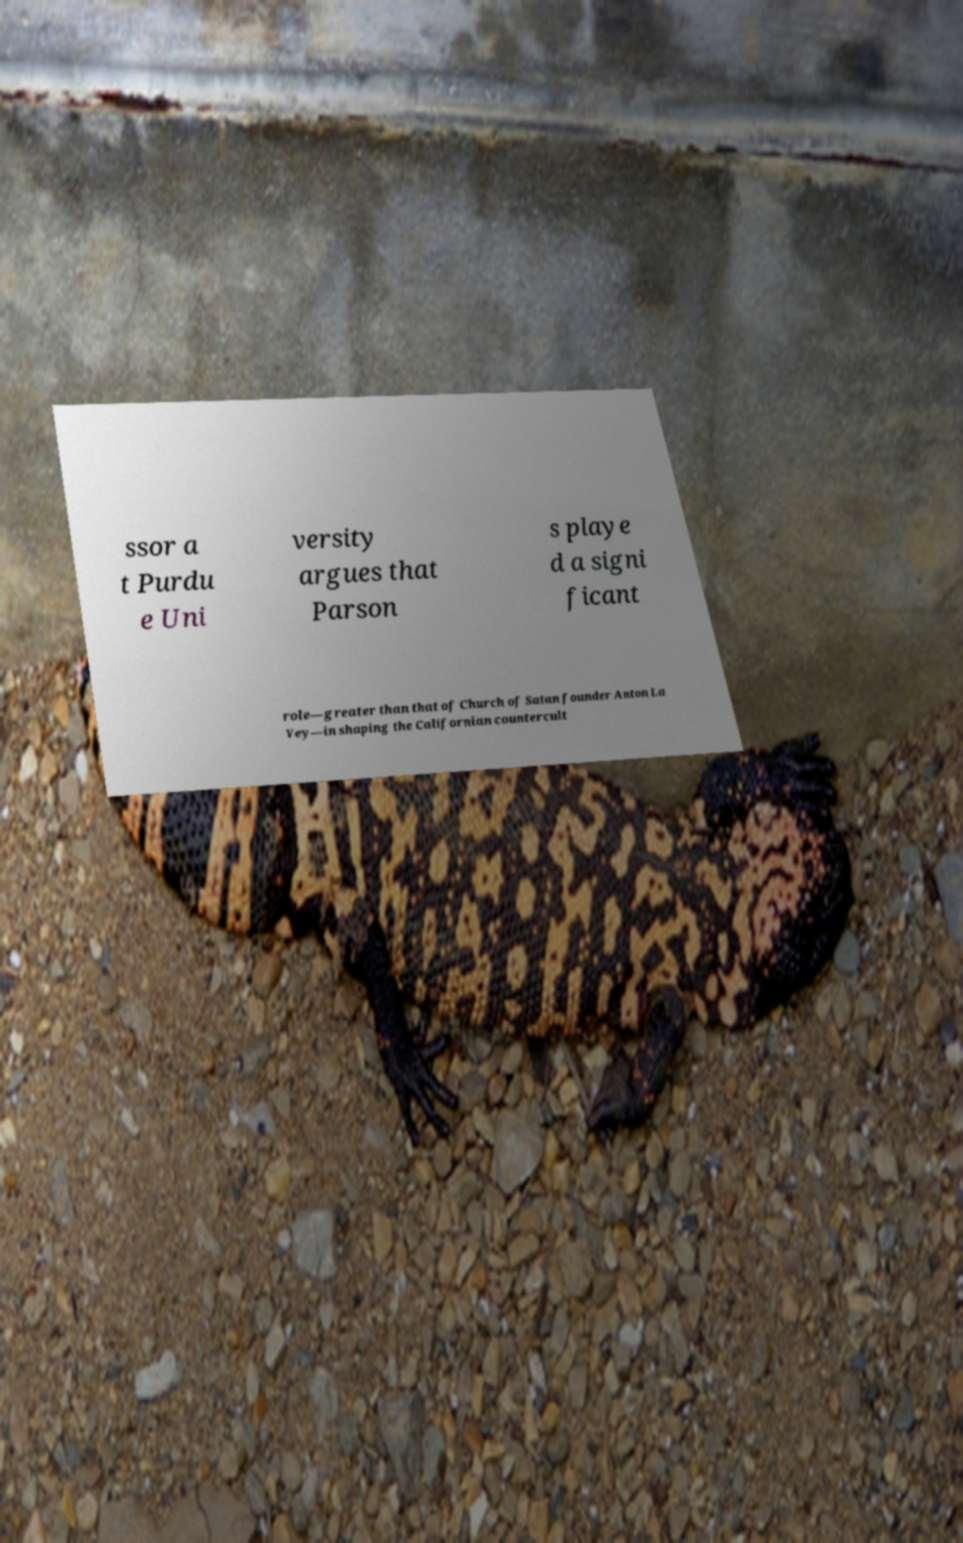What messages or text are displayed in this image? I need them in a readable, typed format. ssor a t Purdu e Uni versity argues that Parson s playe d a signi ficant role—greater than that of Church of Satan founder Anton La Vey—in shaping the Californian countercult 